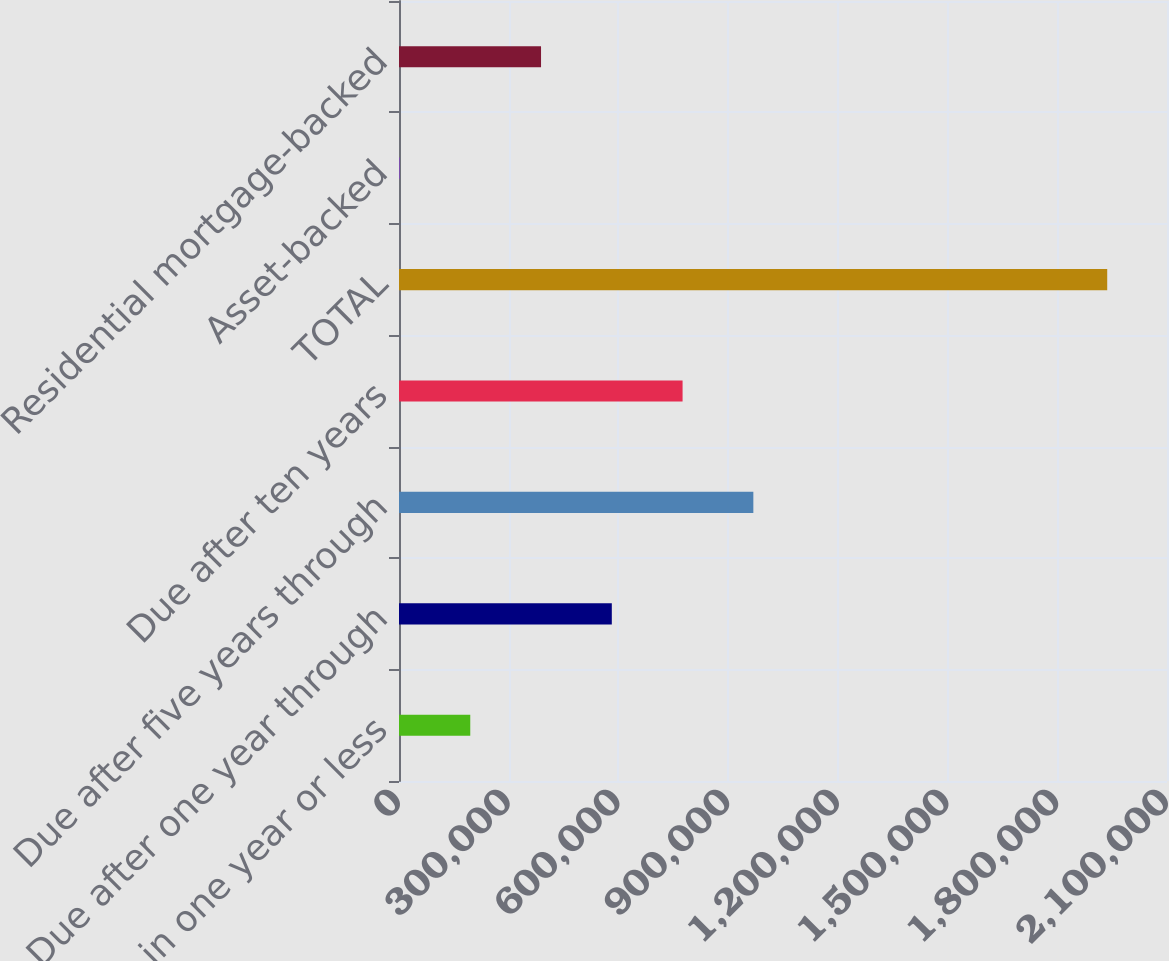<chart> <loc_0><loc_0><loc_500><loc_500><bar_chart><fcel>Due in one year or less<fcel>Due after one year through<fcel>Due after five years through<fcel>Due after ten years<fcel>TOTAL<fcel>Asset-backed<fcel>Residential mortgage-backed<nl><fcel>194858<fcel>581892<fcel>968928<fcel>775410<fcel>1.93652e+06<fcel>1340<fcel>388375<nl></chart> 